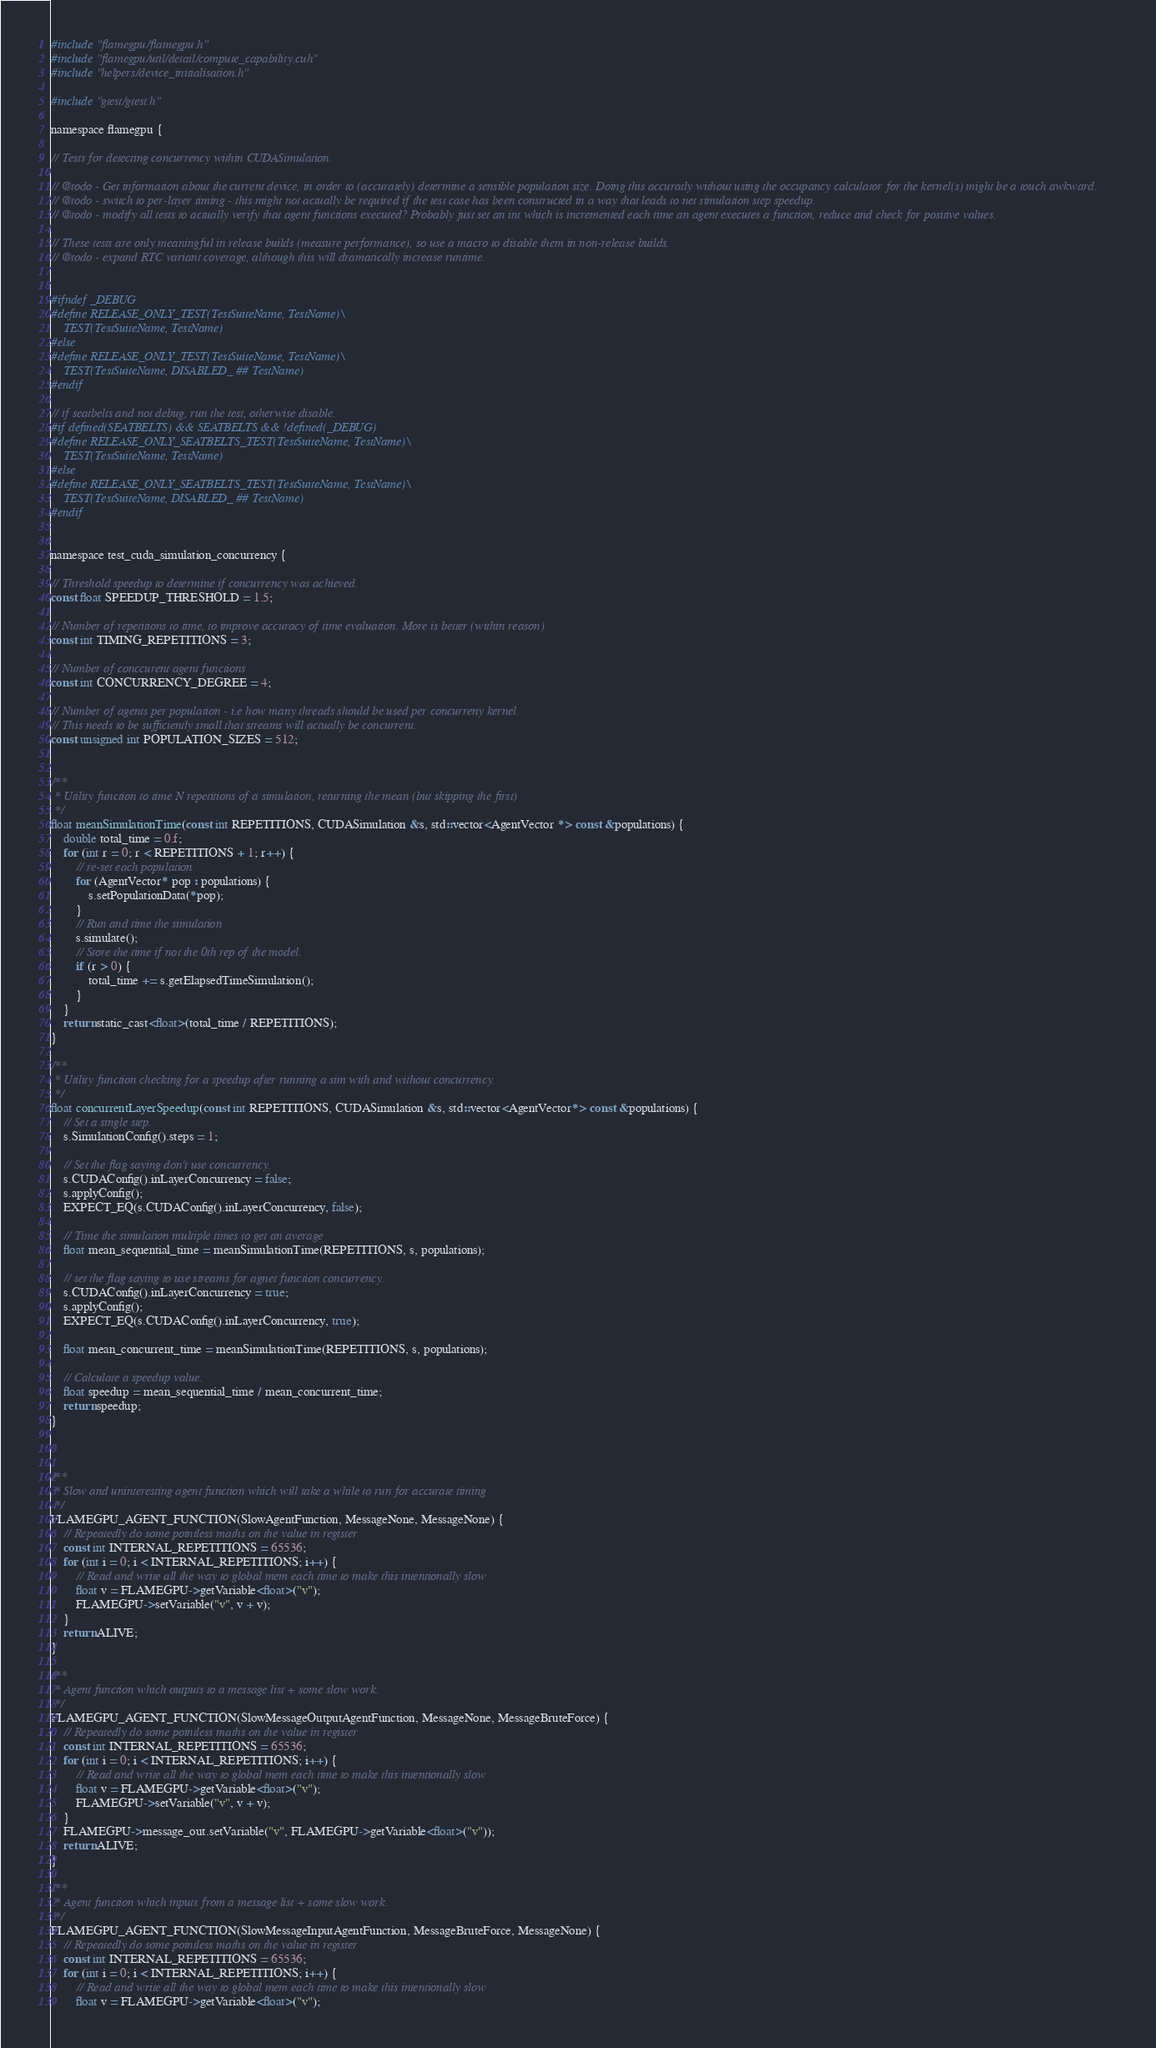Convert code to text. <code><loc_0><loc_0><loc_500><loc_500><_Cuda_>#include "flamegpu/flamegpu.h"
#include "flamegpu/util/detail/compute_capability.cuh"
#include "helpers/device_initialisation.h"

#include "gtest/gtest.h"

namespace flamegpu {

// Tests for detecting concurrency within CUDASimulation.

// @todo - Get information about the current device, in order to (accurately) determine a sensible population size. Doing this accuratly without using the occupancy calculator for the kernel(s) might be a touch awkward.
// @todo - switch to per-layer timing - this might not actually be required if the test case has been constructed in a way that leads to net simulation step speedup.
// @todo - modify all tests to actually verify that agent functions executed? Probably just set an int which is incremented each time an agent executes a function, reduce and check for positive values.

// These tests are only meaningful in release builds (measure performance), so use a macro to disable them in non-release builds.
// @todo - expand RTC variant coverage, although this will dramatically increase runtime.


#ifndef _DEBUG
#define RELEASE_ONLY_TEST(TestSuiteName, TestName)\
    TEST(TestSuiteName, TestName)
#else
#define RELEASE_ONLY_TEST(TestSuiteName, TestName)\
    TEST(TestSuiteName, DISABLED_ ## TestName)
#endif

// if seatbelts and not debug, run the test, otherwise disable.
#if defined(SEATBELTS) && SEATBELTS && !defined(_DEBUG)
#define RELEASE_ONLY_SEATBELTS_TEST(TestSuiteName, TestName)\
    TEST(TestSuiteName, TestName)
#else
#define RELEASE_ONLY_SEATBELTS_TEST(TestSuiteName, TestName)\
    TEST(TestSuiteName, DISABLED_ ## TestName)
#endif


namespace test_cuda_simulation_concurrency {

// Threshold speedup to determine if concurrency was achieved.
const float SPEEDUP_THRESHOLD = 1.5;

// Number of repetitions to time, to improve accuracy of time evaluation. More is better (within reason)
const int TIMING_REPETITIONS = 3;

// Number of conccurent agent functions
const int CONCURRENCY_DEGREE = 4;

// Number of agents per population - i.e how many threads should be used per concurreny kernel.
// This needs to be sufficiently small that streams will actually be concurrent.
const unsigned int POPULATION_SIZES = 512;


/** 
 * Utility function to time N repetitions of a simulation, returning the mean (but skipping the first)
 */
float meanSimulationTime(const int REPETITIONS, CUDASimulation &s, std::vector<AgentVector *> const &populations) {
    double total_time = 0.f;
    for (int r = 0; r < REPETITIONS + 1; r++) {
        // re-set each population
        for (AgentVector* pop : populations) {
            s.setPopulationData(*pop);
        }
        // Run and time the simulation
        s.simulate();
        // Store the time if not the 0th rep of the model.
        if (r > 0) {
            total_time += s.getElapsedTimeSimulation();
        }
    }
    return static_cast<float>(total_time / REPETITIONS);
}

/** 
 * Utility function checking for a speedup after running a sim with and without concurrency.
 */
float concurrentLayerSpeedup(const int REPETITIONS, CUDASimulation &s, std::vector<AgentVector*> const &populations) {
    // Set a single step.
    s.SimulationConfig().steps = 1;

    // Set the flag saying don't use concurrency.
    s.CUDAConfig().inLayerConcurrency = false;
    s.applyConfig();
    EXPECT_EQ(s.CUDAConfig().inLayerConcurrency, false);

    // Time the simulation multiple times to get an average
    float mean_sequential_time = meanSimulationTime(REPETITIONS, s, populations);

    // set the flag saying to use streams for agnet function concurrency.
    s.CUDAConfig().inLayerConcurrency = true;
    s.applyConfig();
    EXPECT_EQ(s.CUDAConfig().inLayerConcurrency, true);

    float mean_concurrent_time = meanSimulationTime(REPETITIONS, s, populations);

    // Calculate a speedup value.
    float speedup = mean_sequential_time / mean_concurrent_time;
    return speedup;
}



/**
 * Slow and uninteresting agent function which will take a while to run for accurate timing
 */
FLAMEGPU_AGENT_FUNCTION(SlowAgentFunction, MessageNone, MessageNone) {
    // Repeatedly do some pointless maths on the value in register
    const int INTERNAL_REPETITIONS = 65536;
    for (int i = 0; i < INTERNAL_REPETITIONS; i++) {
        // Read and write all the way to global mem each time to make this intentionally slow
        float v = FLAMEGPU->getVariable<float>("v");
        FLAMEGPU->setVariable("v", v + v);
    }
    return ALIVE;
}

/**
 * Agent function which outputs to a message list + some slow work.
 */
FLAMEGPU_AGENT_FUNCTION(SlowMessageOutputAgentFunction, MessageNone, MessageBruteForce) {
    // Repeatedly do some pointless maths on the value in register
    const int INTERNAL_REPETITIONS = 65536;
    for (int i = 0; i < INTERNAL_REPETITIONS; i++) {
        // Read and write all the way to global mem each time to make this intentionally slow
        float v = FLAMEGPU->getVariable<float>("v");
        FLAMEGPU->setVariable("v", v + v);
    }
    FLAMEGPU->message_out.setVariable("v", FLAMEGPU->getVariable<float>("v"));
    return ALIVE;
}

/**
 * Agent function which inputs from a message list + some slow work.
 */
FLAMEGPU_AGENT_FUNCTION(SlowMessageInputAgentFunction, MessageBruteForce, MessageNone) {
    // Repeatedly do some pointless maths on the value in register
    const int INTERNAL_REPETITIONS = 65536;
    for (int i = 0; i < INTERNAL_REPETITIONS; i++) {
        // Read and write all the way to global mem each time to make this intentionally slow
        float v = FLAMEGPU->getVariable<float>("v");</code> 